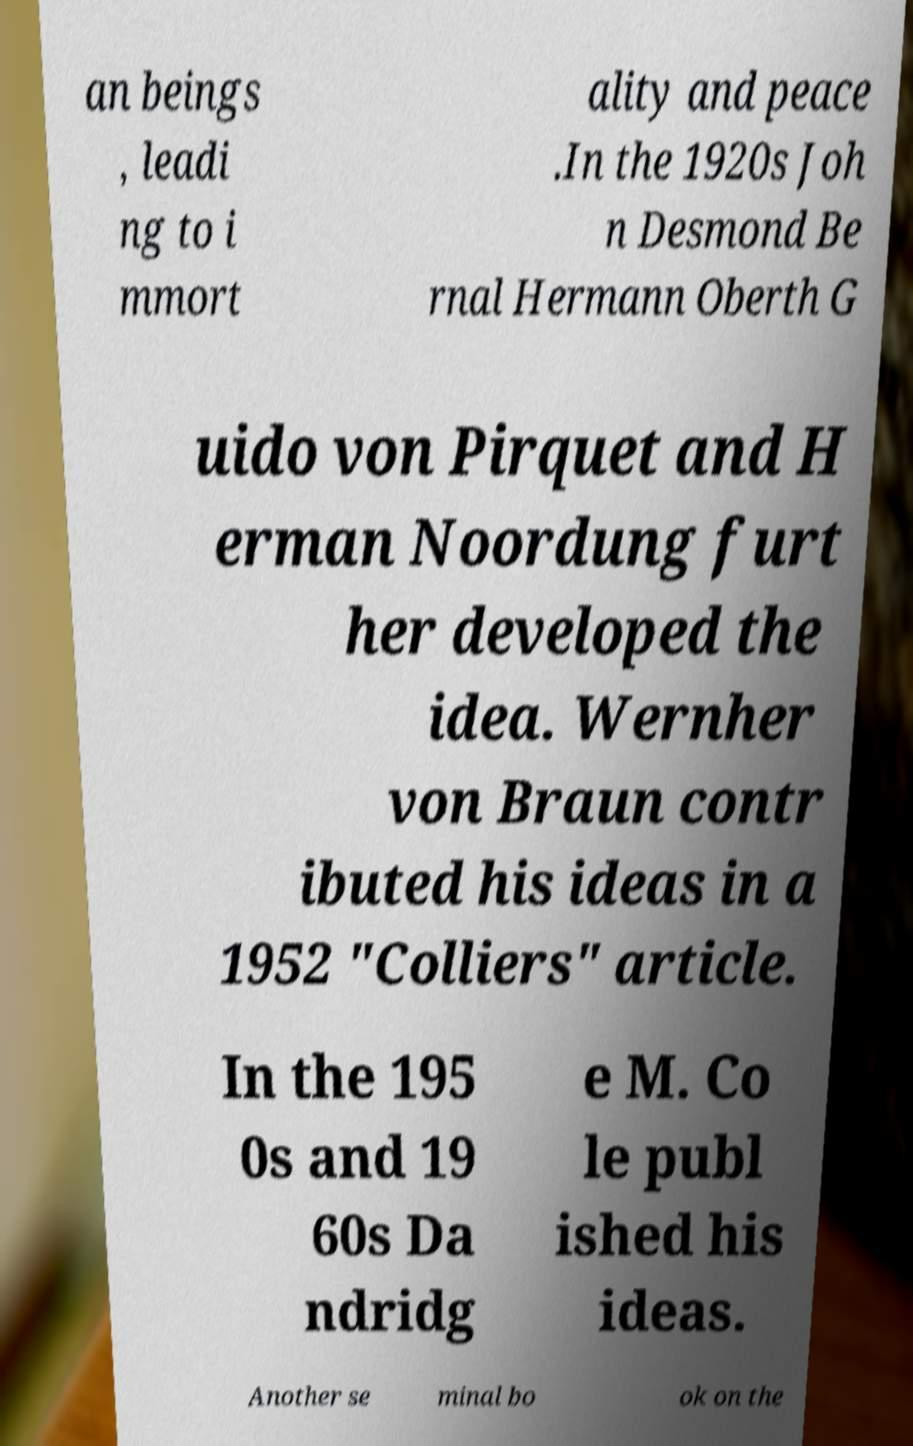Can you read and provide the text displayed in the image?This photo seems to have some interesting text. Can you extract and type it out for me? an beings , leadi ng to i mmort ality and peace .In the 1920s Joh n Desmond Be rnal Hermann Oberth G uido von Pirquet and H erman Noordung furt her developed the idea. Wernher von Braun contr ibuted his ideas in a 1952 "Colliers" article. In the 195 0s and 19 60s Da ndridg e M. Co le publ ished his ideas. Another se minal bo ok on the 